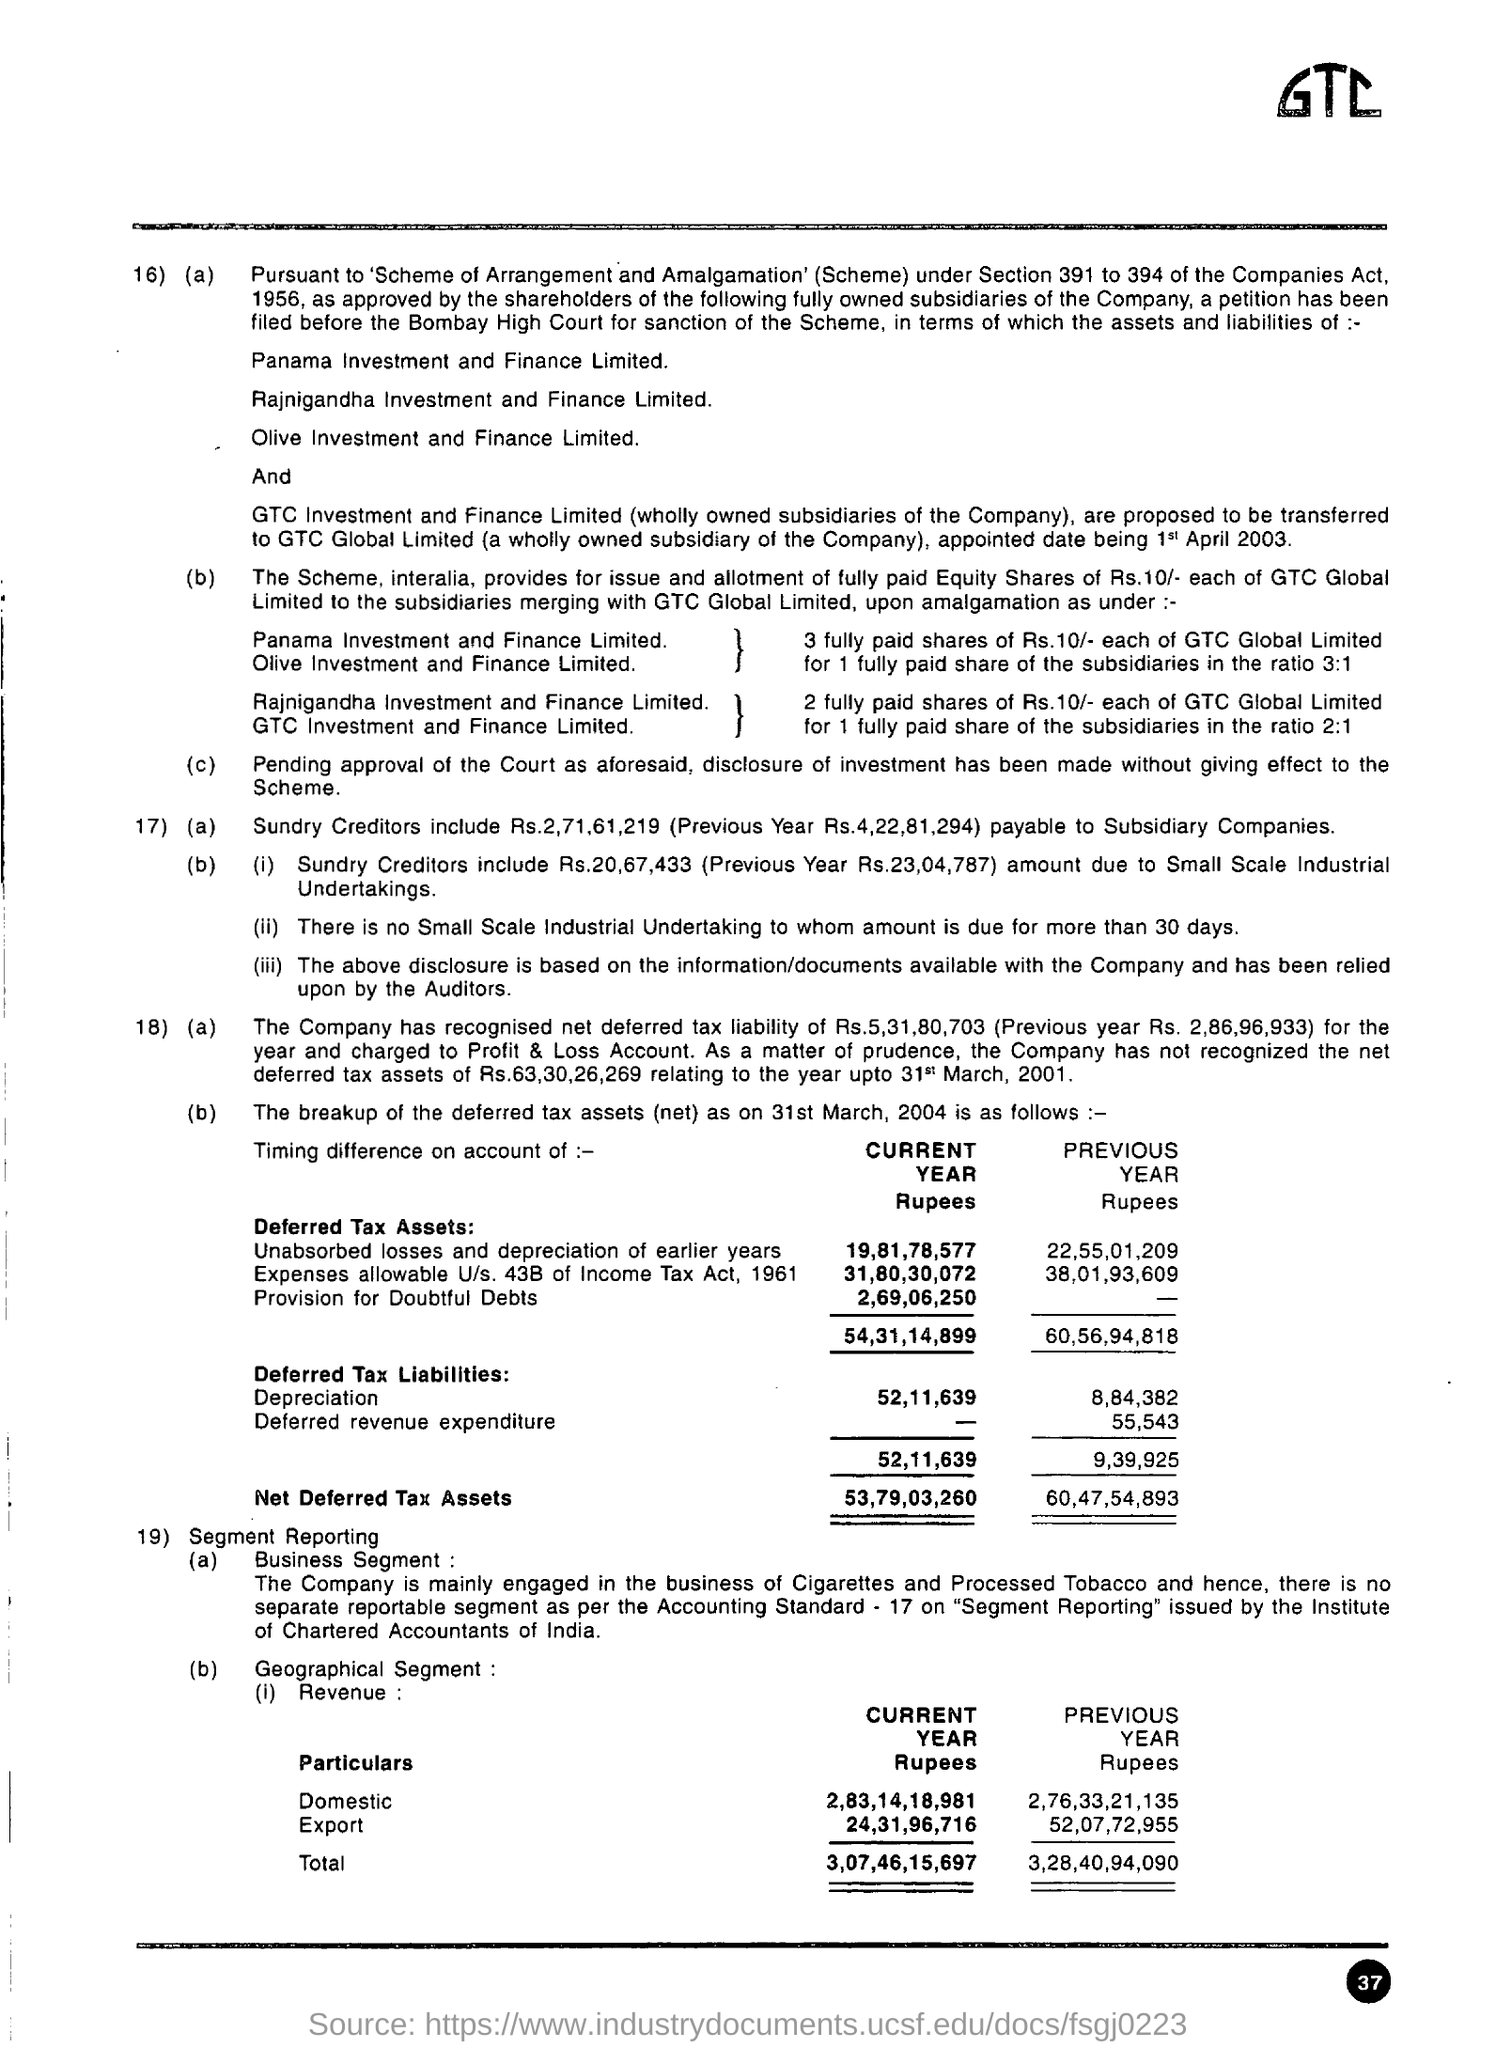What is the text written in the top right?
Provide a succinct answer. GTC. 